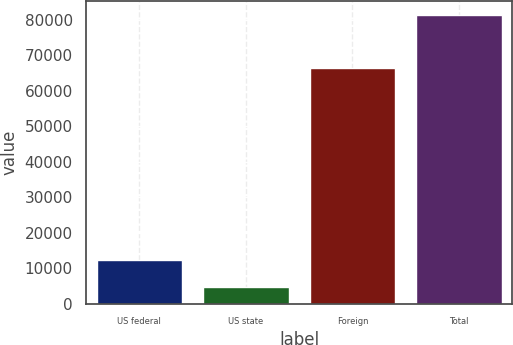Convert chart. <chart><loc_0><loc_0><loc_500><loc_500><bar_chart><fcel>US federal<fcel>US state<fcel>Foreign<fcel>Total<nl><fcel>12324.6<fcel>4660<fcel>66306<fcel>81306<nl></chart> 